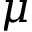<formula> <loc_0><loc_0><loc_500><loc_500>\mu</formula> 